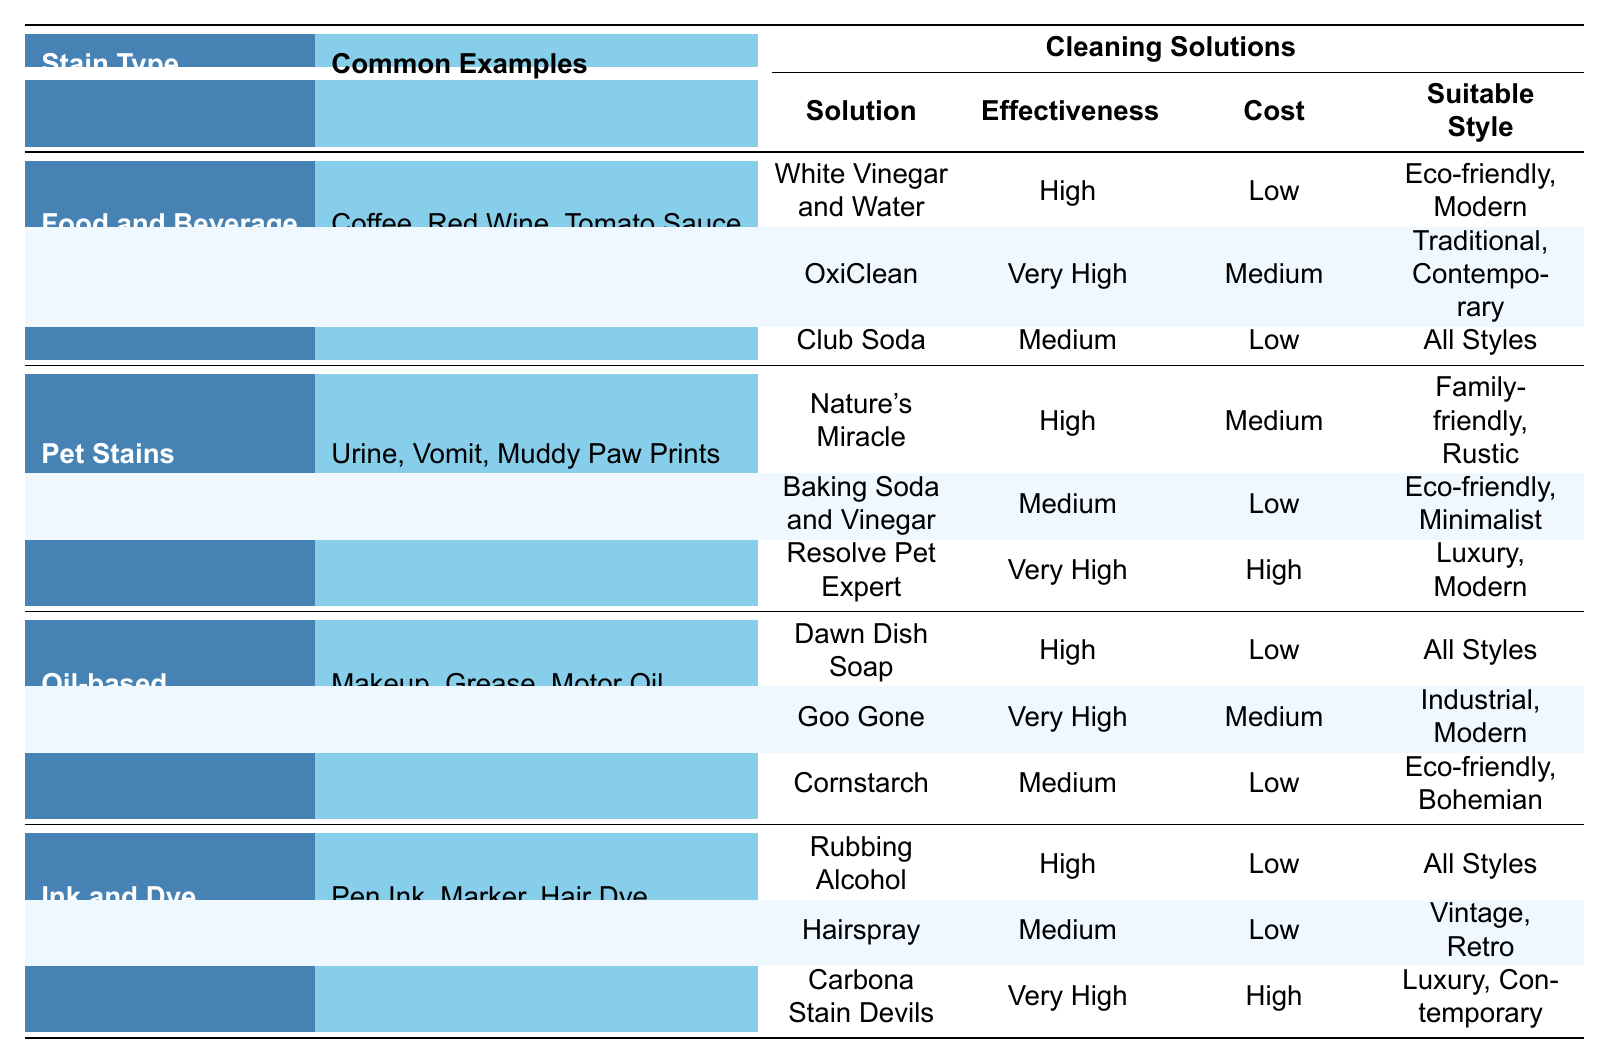What are three examples of food and beverage stains listed in the table? The table specifically lists "Coffee," "Red Wine," and "Tomato Sauce" as common examples under the Food and Beverage stain type.
Answer: Coffee, Red Wine, Tomato Sauce Which cleaning solution for pet stains is considered very high in effectiveness? In the table, "Resolve Pet Expert" is marked as having "Very High" effectiveness among the cleaning solutions for pet stains.
Answer: Resolve Pet Expert Is "Cornstarch" suitable for all styles of carpet? The table indicates that "Cornstarch" is suitable for "Eco-friendly, Bohemian" styles, but it does not list it as suitable for all styles.
Answer: No Which cleaning solution has the lowest cost in dealing with oil-based stains? The table shows "Dawn Dish Soap" and "Cornstarch" both as having "Low" cost, but among these, it lists "Dawn Dish Soap" first.
Answer: Dawn Dish Soap Which carpet stain type has the greatest number of cleaning solutions categorized as very high in effectiveness? Scanning through the cleaning solutions for each stain type, both "Food and Beverage" and "Pet Stains" have one solution marked as very high, but "Ink and Dye" has one too. So none holds a majority with multiple very high options.
Answer: None If a homeowner prefers eco-friendly solutions only, which cleaning solution would be the most suitable for food and beverage stains? The table indicates that "White Vinegar and Water" is marked as eco-friendly with high effectiveness for food and beverage stains.
Answer: White Vinegar and Water What is the average effectiveness rating of the cleaning solutions for pet stains? The effectiveness ratings, on a scale from Low, Medium, High, to Very High are: High (1), Medium (1), Very High (1). If we assign numerical values: Low=1, Medium=2, High=3, Very High=4, the average (3+2+4)/3 = 3 (High) overall.
Answer: High What is the most expensive cleaning solution for ink and dye stains? The table lists "Carbona Stain Devils" as the only cleaning solution with a "High" cost for ink and dye stains, making it the most expensive listed for this category.
Answer: Carbona Stain Devils How many cleaning solutions are categorized as medium effectiveness for pet stains? The table indicates that there is one cleaning solution categorized as medium effectiveness for pet stains, which is "Baking Soda and Vinegar."
Answer: One Which cleaning solution can be used on all styles for food and beverage stains? "Club Soda" is marked as suitable for "All Styles" among the cleaning solutions for food and beverage stains.
Answer: Club Soda 